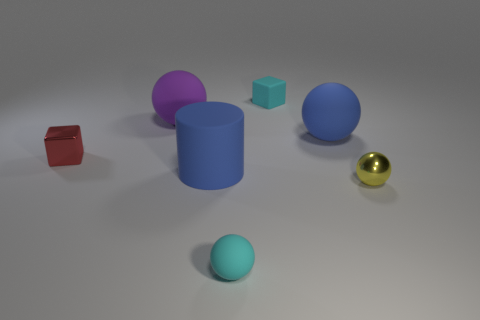Compare the sizes of the gold and turquoise balls. The gold ball is distinctly smaller than the turquoise ball. You can tell by comparing their sizes relative to other objects in the scene, particularly the blue ball that helps provide a point of reference for their scale. 